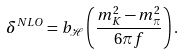<formula> <loc_0><loc_0><loc_500><loc_500>\delta ^ { N L O } = b _ { \mathcal { H } } \left ( \frac { m _ { K } ^ { 2 } - m _ { \pi } ^ { 2 } } { 6 \pi f } \right ) .</formula> 